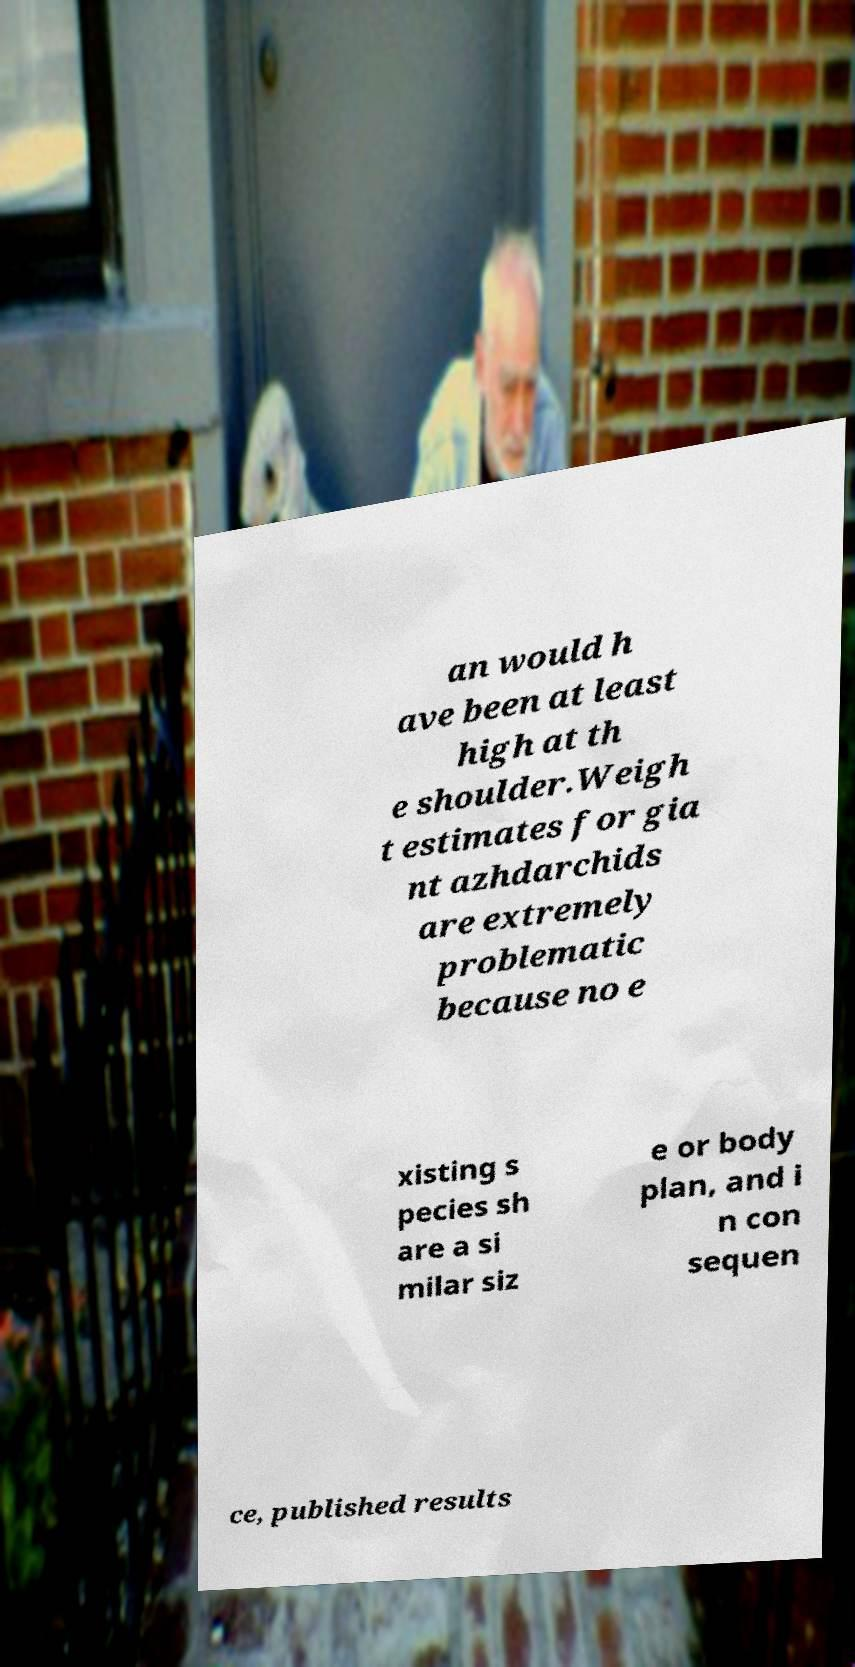What messages or text are displayed in this image? I need them in a readable, typed format. an would h ave been at least high at th e shoulder.Weigh t estimates for gia nt azhdarchids are extremely problematic because no e xisting s pecies sh are a si milar siz e or body plan, and i n con sequen ce, published results 